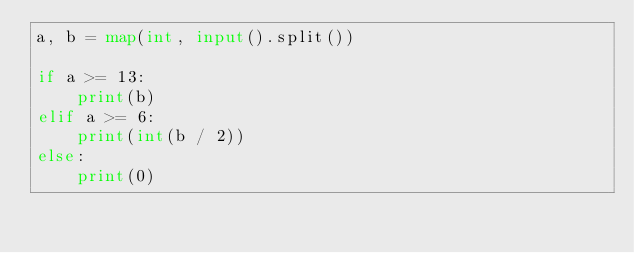Convert code to text. <code><loc_0><loc_0><loc_500><loc_500><_Python_>a, b = map(int, input().split())

if a >= 13:
    print(b)
elif a >= 6:
    print(int(b / 2))
else:
    print(0)</code> 